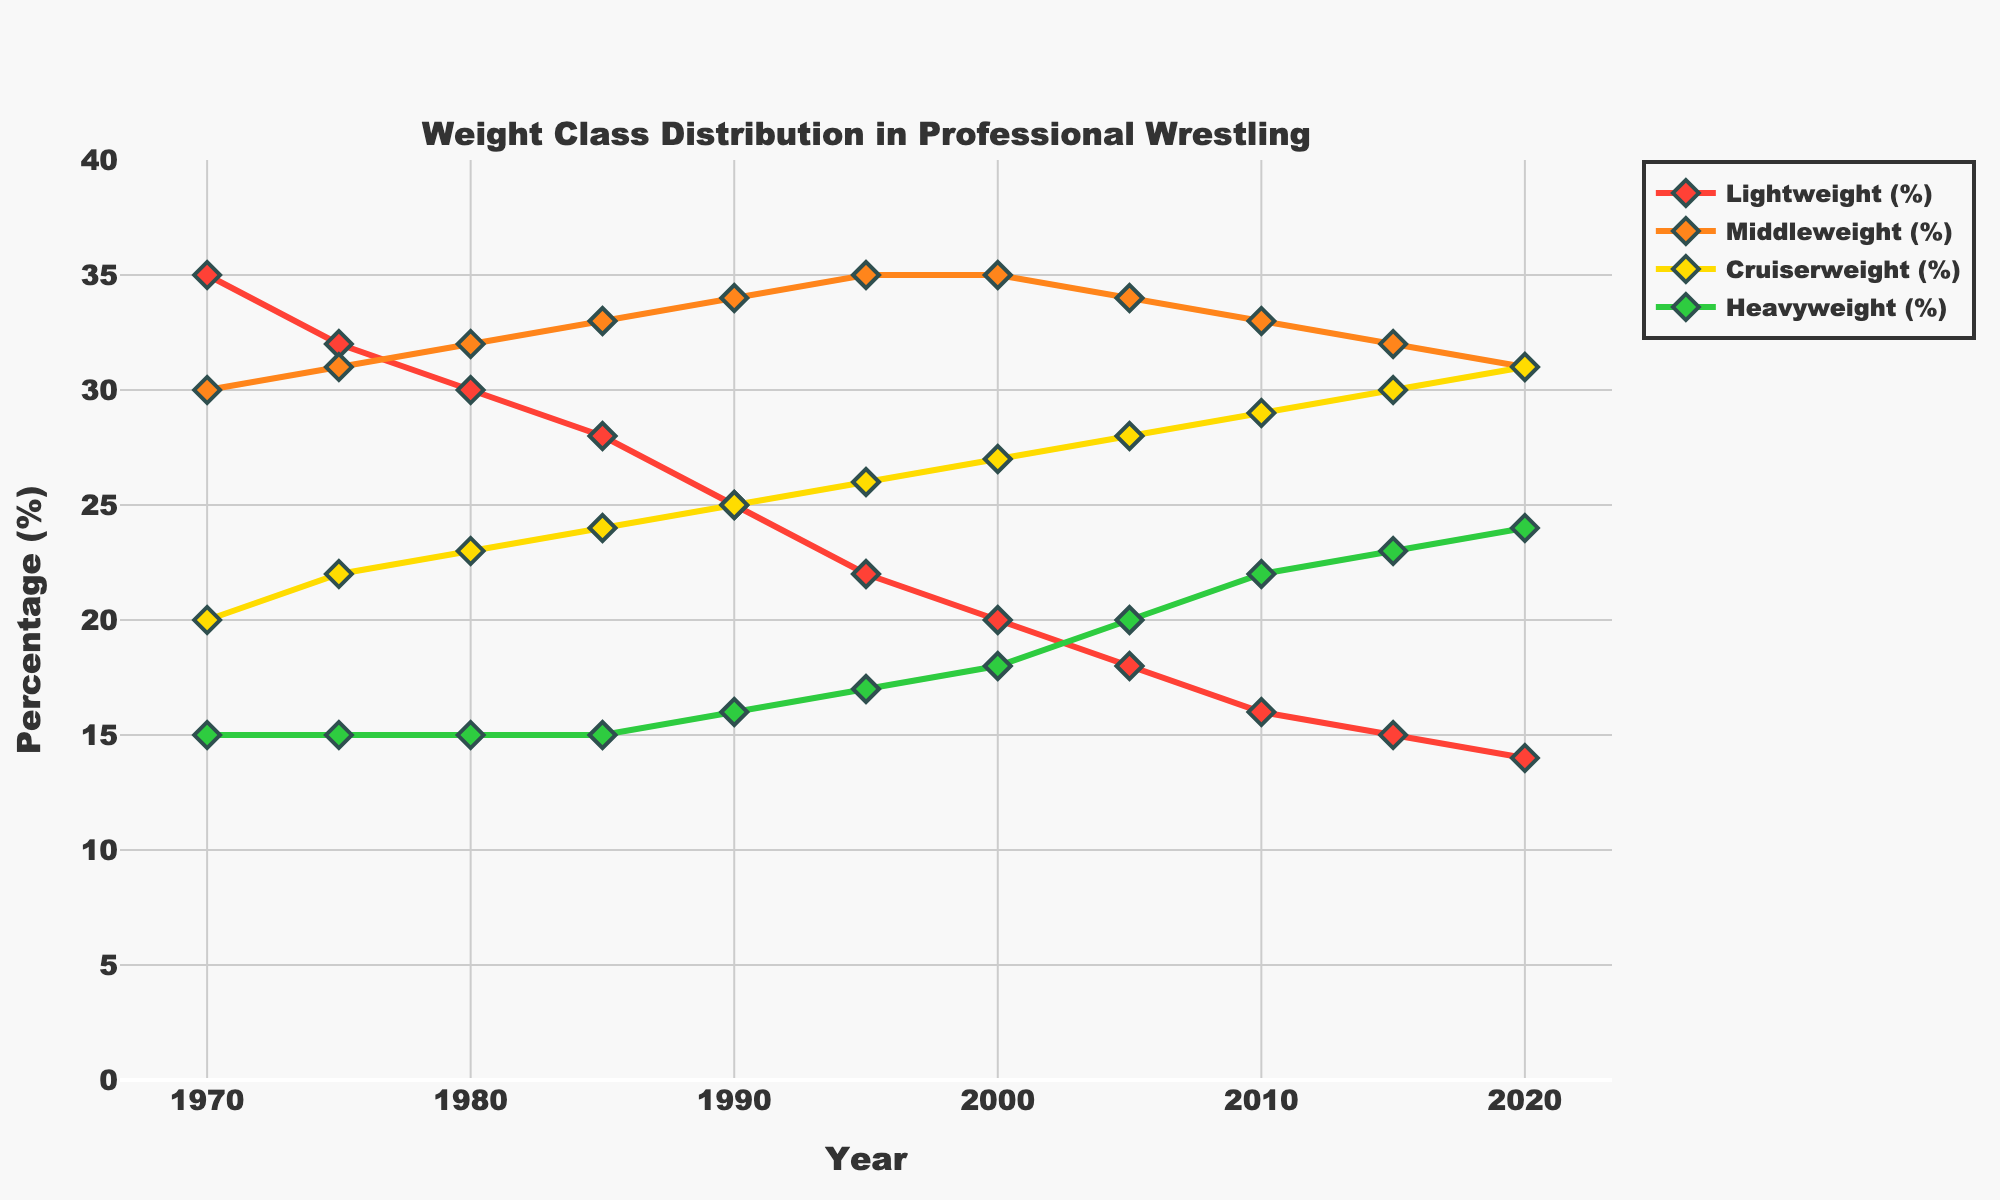What's the highest percentage of Heavyweight wrestlers over the 50 years? The highest percentage of Heavyweight wrestlers is 24% in 2020. By examining the line associated with Heavyweight category (green) in the figure, we see it reaches 24% in the final year (2020).
Answer: 24% Which weight class showed the consistent increase over the years? By observing the individual lines for each weight class, the Cruiserweight class shows a consistent increase from 20% in 1970 to 31% in 2020. The orange line gradually rises without any dips.
Answer: Cruiserweight In which year did Middleweight wrestlers reach their highest percentage? The Middleweight percentage reached its highest point of 35% in 1995. This is evident by examining the trend of the yellow line which peaks in 1995.
Answer: 1995 In which decade did the Lightweight percentage drop the most significantly? The steepest decline for the Lightweight category (red line) occurred between 1970 and 1980, dropping from 35% to 30%, a decrease of 5 percentage points within a decade.
Answer: 1970-1980 Which two weight classes had equal percentages in 1970? In 1970, both Middleweight and Heavyweight wrestlers had equal percentages, as can be observed from the chart where the lines intersect at the same value of 15%.
Answer: Middleweight and Heavyweight What is the difference in percentage points between Cruiserweight and Heavyweight in 2020? In 2020, the Cruiserweight class is 31%, and Heavyweight is 24%. The difference is 31% - 24% = 7 percentage points.
Answer: 7 percentage points Which weight class had the highest representation in 1985? In 1985, the Middleweight class had the highest representation at 33%. This is clear by looking at the peak of the yellow line for that year.
Answer: Middleweight How many years did the Heavyweight percentage remain at 15%? The Heavyweight percentage remains at 15% for 15 years, from 1970 to 1985. This is shown by the flat green line at 15% for three consecutive data points.
Answer: 15 years Which weight class showed the largest percentage increase between 1970 and 2020? The Cruiserweight class showed the largest increase, rising from 20% in 1970 to 31% in 2020, an increase of 11 percentage points. By comparing the start and end points of each line, we see the orange line (Cruiserweight) having the largest positive change.
Answer: Cruiserweight 